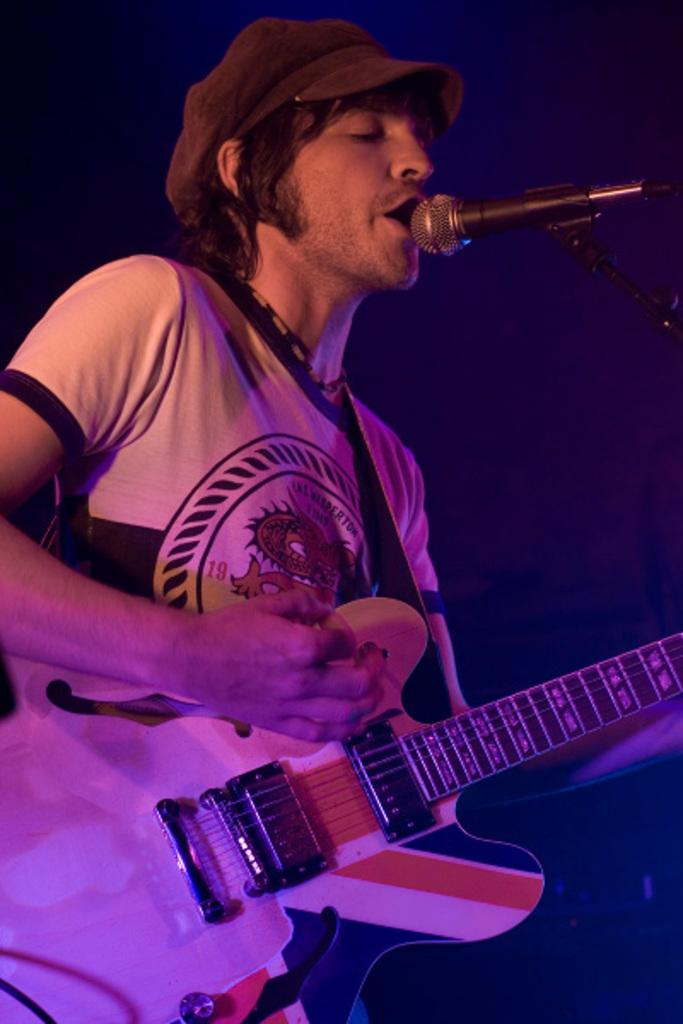What is the man in the image doing? The man is playing a guitar and singing. What object is in front of the man? There is a microphone in front of the man. What type of headwear is the man wearing? The man is wearing a cap. How would you describe the lighting in the image? The background of the image is dark. What type of friction can be seen between the guitar strings and the man's fingers in the image? There is no visible friction between the guitar strings and the man's fingers in the image. What type of metal is the microphone made of in the image? The type of metal the microphone is made of cannot be determined from the image. 